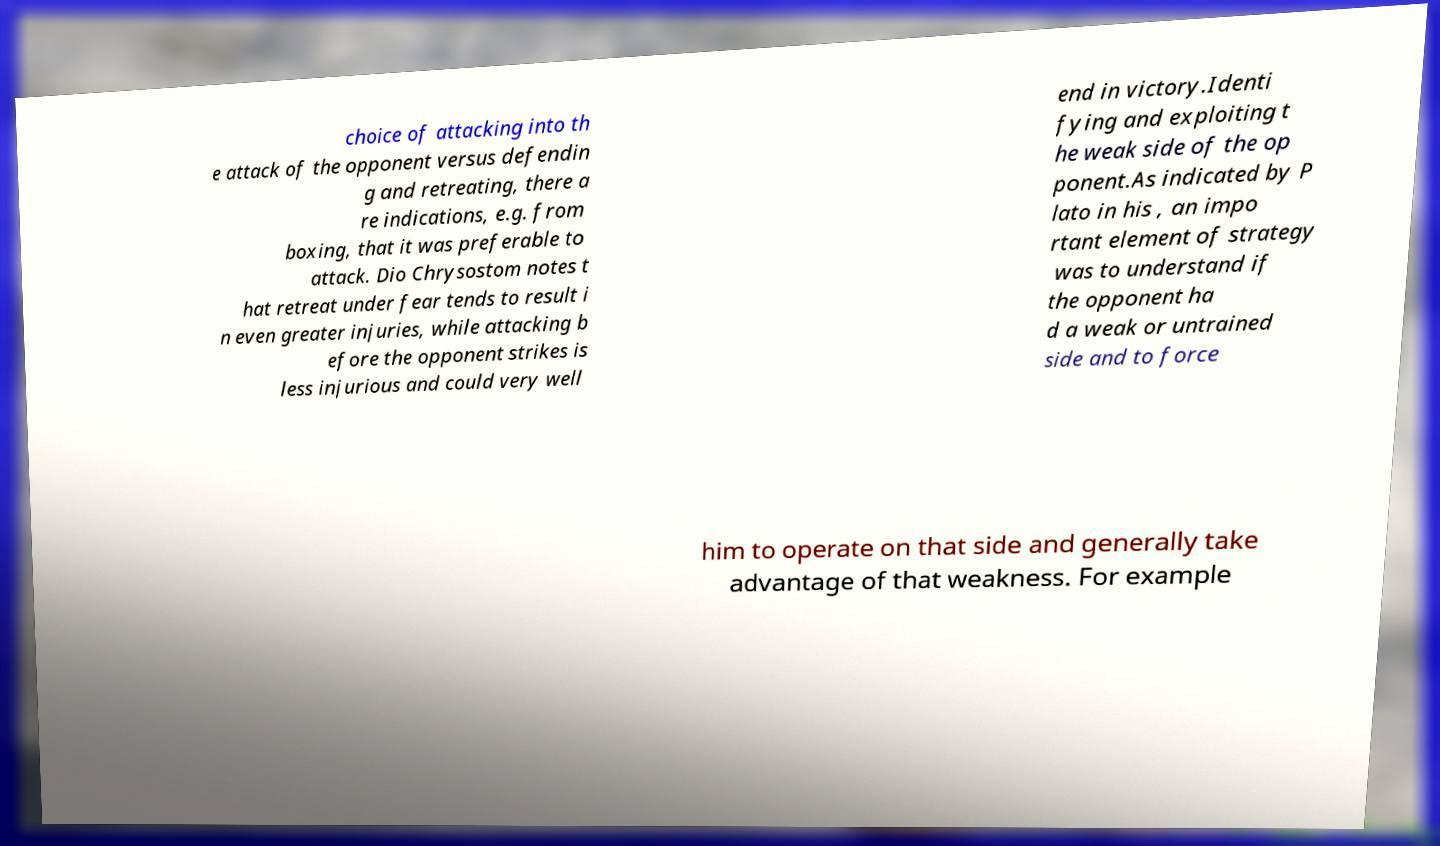There's text embedded in this image that I need extracted. Can you transcribe it verbatim? choice of attacking into th e attack of the opponent versus defendin g and retreating, there a re indications, e.g. from boxing, that it was preferable to attack. Dio Chrysostom notes t hat retreat under fear tends to result i n even greater injuries, while attacking b efore the opponent strikes is less injurious and could very well end in victory.Identi fying and exploiting t he weak side of the op ponent.As indicated by P lato in his , an impo rtant element of strategy was to understand if the opponent ha d a weak or untrained side and to force him to operate on that side and generally take advantage of that weakness. For example 